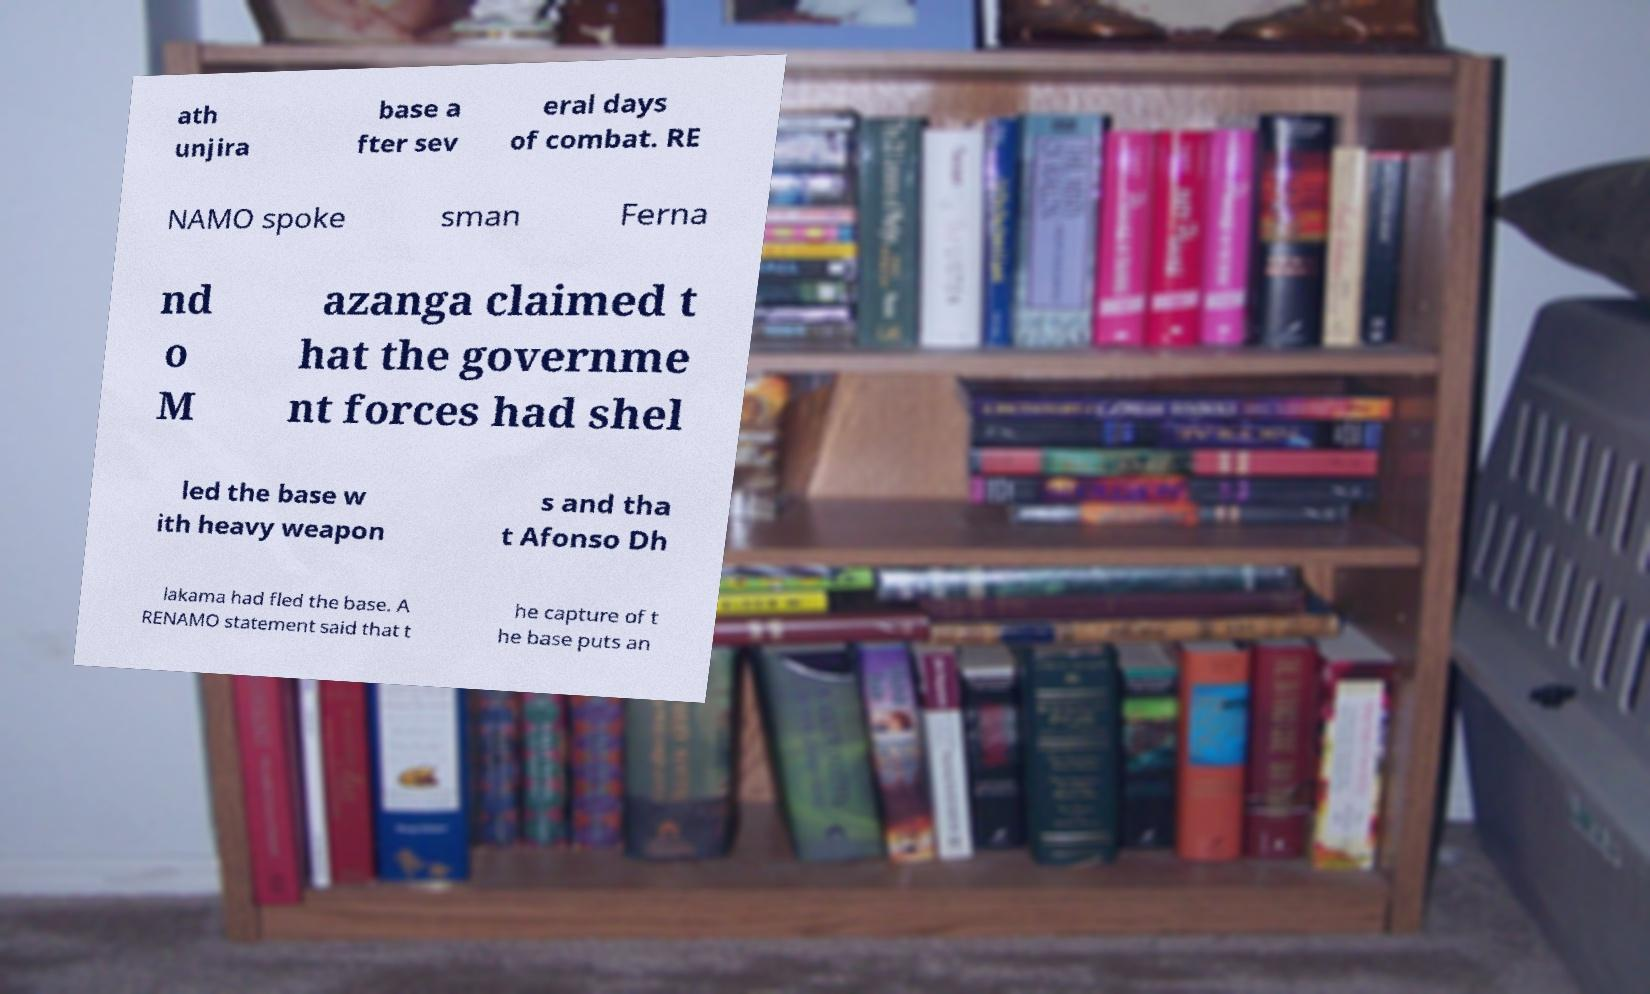Could you assist in decoding the text presented in this image and type it out clearly? ath unjira base a fter sev eral days of combat. RE NAMO spoke sman Ferna nd o M azanga claimed t hat the governme nt forces had shel led the base w ith heavy weapon s and tha t Afonso Dh lakama had fled the base. A RENAMO statement said that t he capture of t he base puts an 